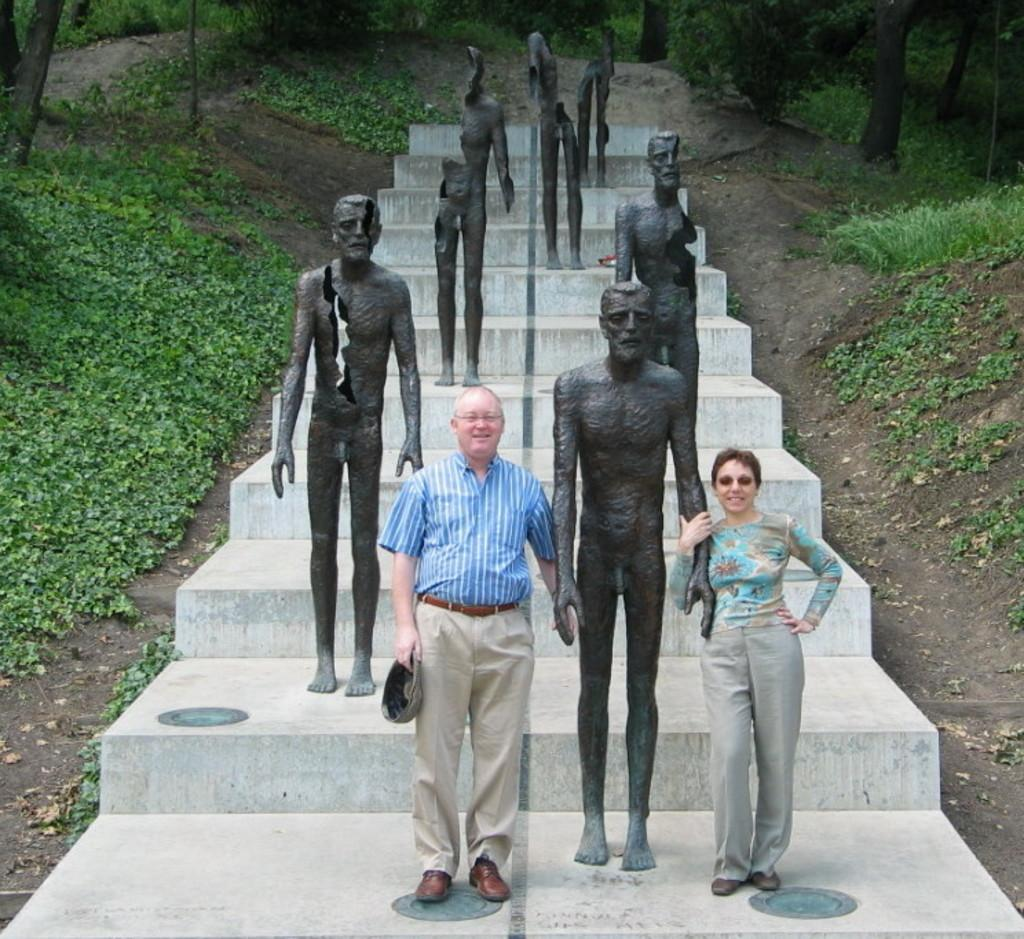How many people are present in the image? There are two persons standing in the image. What else can be seen in the image besides the people? There are statues, stairs, plants, and trees in the image. Can you describe the architectural feature in the image? Yes, there are stairs in the image. What type of vegetation is visible in the background of the image? There are plants and trees in the background of the image. What type of nail is being used to hold the statue in place in the image? There is no nail visible in the image, and the statues do not appear to be held in place by any visible means. 